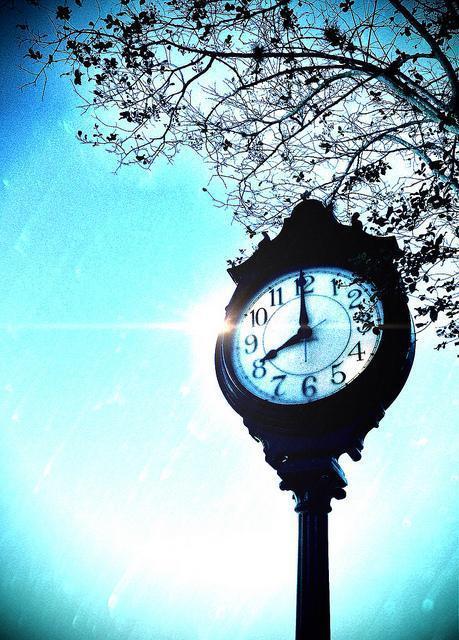How many headlights does the motorcycle have?
Give a very brief answer. 0. 